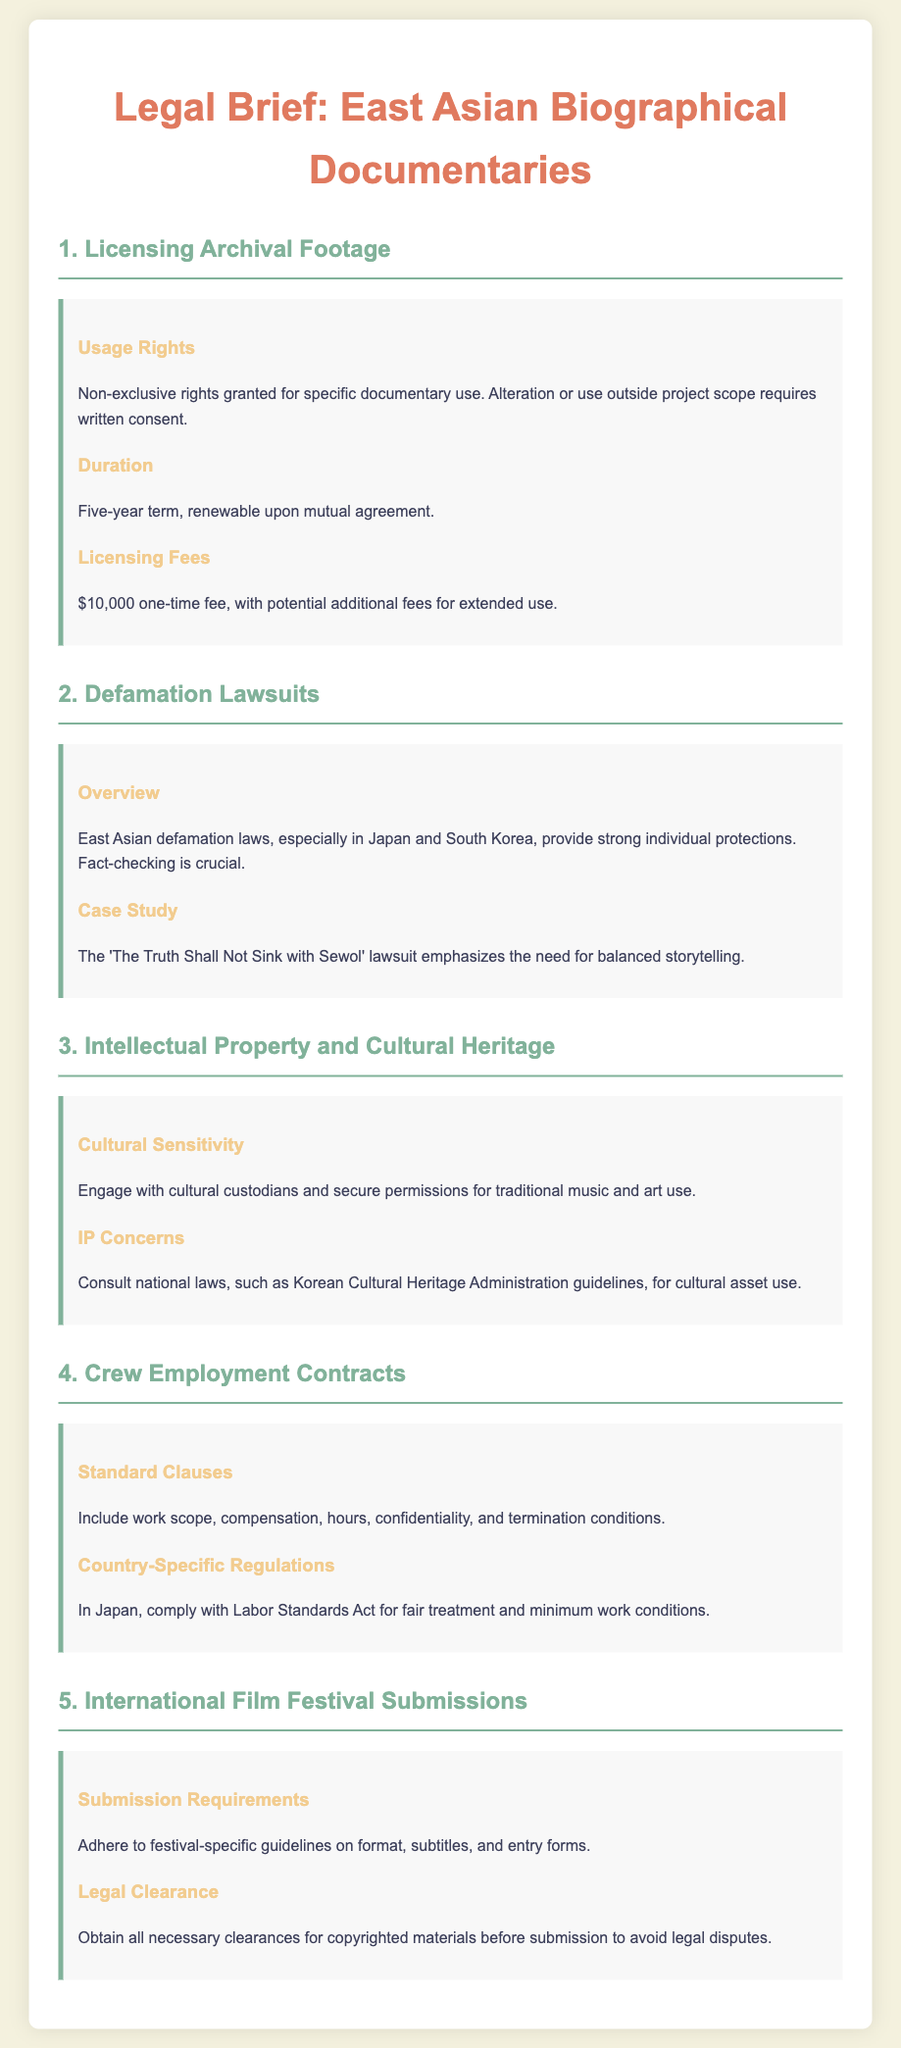What is the licensing fee for archival footage? The licensing fee for archival footage is stated as a one-time payment in the document.
Answer: $10,000 How long is the term for the licensing agreement? The term of the licensing agreement is specified as a duration in the document.
Answer: Five years What is crucial to avoid defamation lawsuits in East Asia? The document highlights the importance of a specific practice to mitigate legal risks.
Answer: Fact-checking Which country’s regulations must crew employment contracts comply with? The document mentions a specific law that applies to a country relevant to crew employment contracts.
Answer: Japan What type of rights are granted for archival footage usage? The rights pertaining to archival footage usage are categorized in the document.
Answer: Non-exclusive rights What must filmmakers secure when using traditional music and art? The document stresses the need for a certain action regarding cultural elements used in documentaries.
Answer: Permissions What is emphasized in the case study mentioned under defamation lawsuits? The document points out a specific storytelling aspect highlighted in the case study.
Answer: Balanced storytelling What type of clearance is necessary before submitting a documentary to a film festival? The document specifies the type of clearance needed for legal compliance in the submission process.
Answer: Legal clearance What should be included in crew employment contracts? The document lists several important details that must be part of crew contracts.
Answer: Work scope, compensation, hours, confidentiality, and termination conditions 